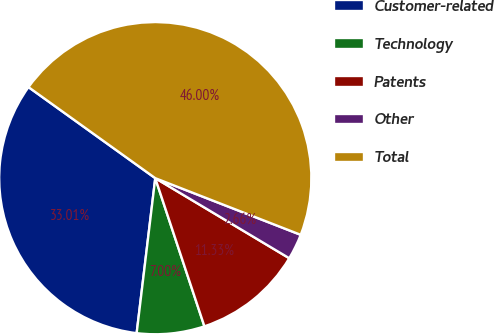<chart> <loc_0><loc_0><loc_500><loc_500><pie_chart><fcel>Customer-related<fcel>Technology<fcel>Patents<fcel>Other<fcel>Total<nl><fcel>33.01%<fcel>7.0%<fcel>11.33%<fcel>2.66%<fcel>46.0%<nl></chart> 